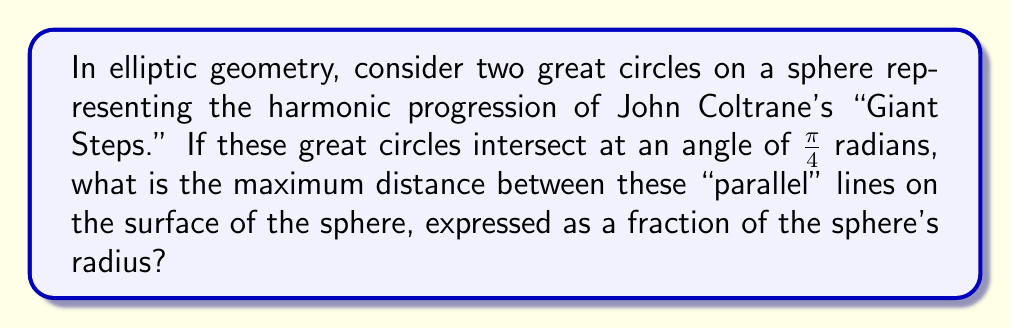Could you help me with this problem? Let's approach this step-by-step:

1) In elliptic geometry, "parallel" lines are great circles that intersect at two antipodal points on a sphere.

2) The angle between these great circles is $\frac{\pi}{4}$ radians, or 45°.

3) The maximum distance between two great circles occurs at the midpoint between their intersection points, which forms a spherical triangle.

4) In this spherical triangle:
   - Two sides are quarter-circles (90° or $\frac{\pi}{2}$ radians)
   - The angle between these sides is $\frac{\pi}{4}$ radians

5) We can use the spherical law of cosines to find the third side of this triangle:

   $$\cos(c) = \cos(a)\cos(b) + \sin(a)\sin(b)\cos(C)$$

   Where $c$ is the side we're looking for, $a$ and $b$ are $\frac{\pi}{2}$, and $C$ is $\frac{\pi}{4}$.

6) Substituting these values:

   $$\cos(c) = \cos(\frac{\pi}{2})\cos(\frac{\pi}{2}) + \sin(\frac{\pi}{2})\sin(\frac{\pi}{2})\cos(\frac{\pi}{4})$$

7) Simplify:
   $$\cos(c) = (0)(0) + (1)(1)(\frac{\sqrt{2}}{2}) = \frac{\sqrt{2}}{2}$$

8) To get $c$, we take the inverse cosine:

   $$c = \arccos(\frac{\sqrt{2}}{2}) = \frac{\pi}{4}$$

9) This angle $c$ represents the maximum distance between the "parallel" lines as a fraction of the sphere's radius.
Answer: $\frac{\pi}{4}$ 